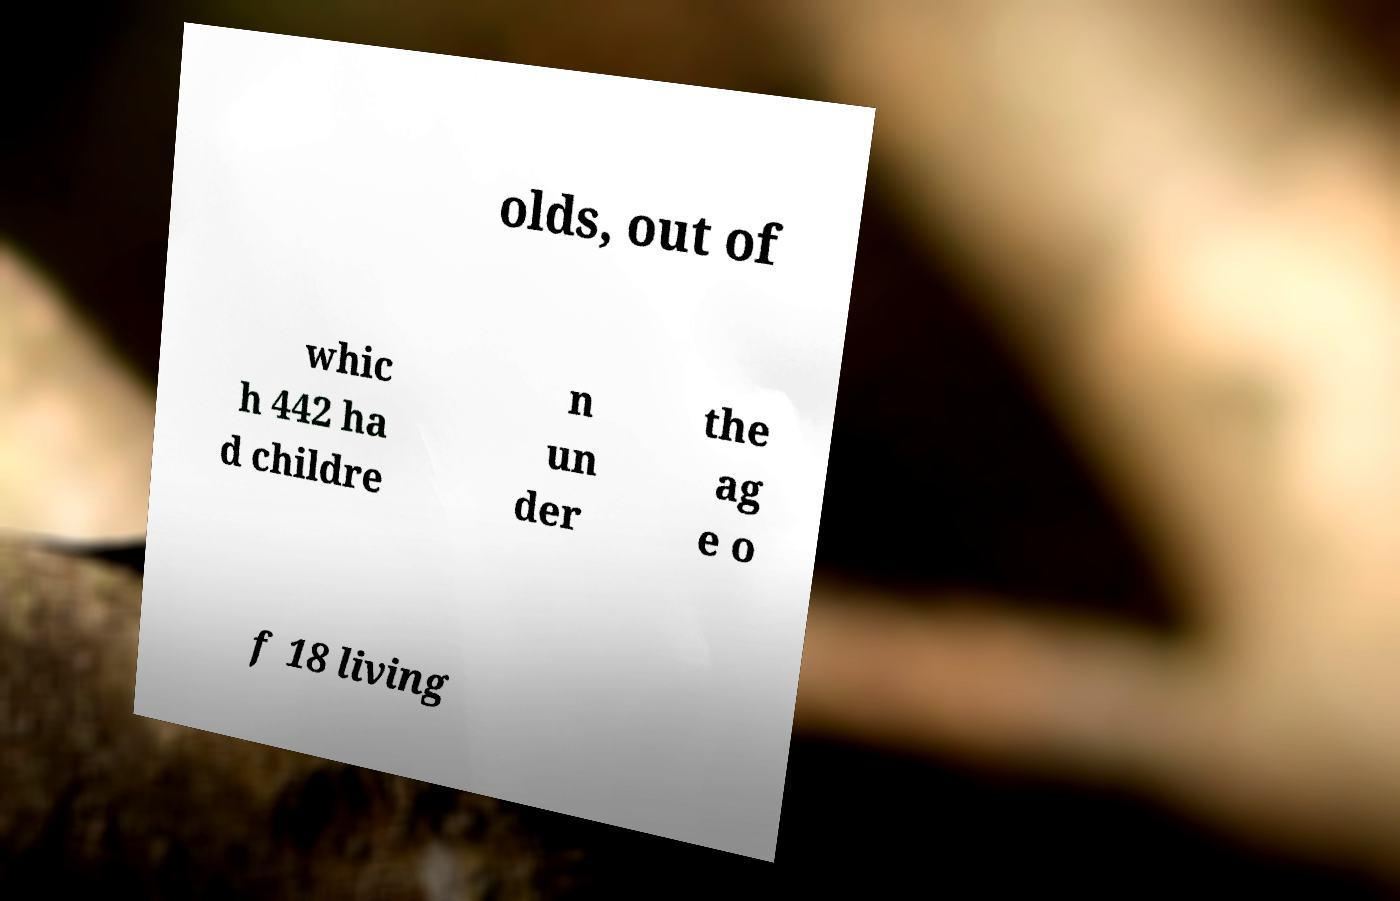Can you accurately transcribe the text from the provided image for me? olds, out of whic h 442 ha d childre n un der the ag e o f 18 living 